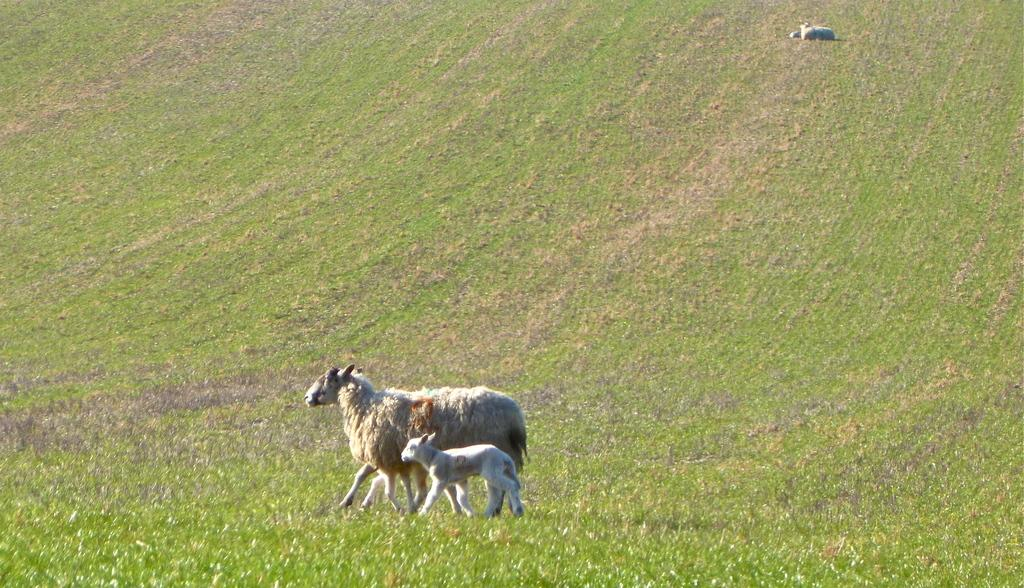What type of vegetation is present on the ground in the image? There is grass on the ground in the image. What animals can be seen in the image? There is a sheep and a lamb in the image. Can you describe the position of the animal at the top of the image? There is an animal sitting at the top of the image. Where is the ghost in the image? There is no ghost present in the image. What type of skin is visible on the sheep in the image? The image does not provide enough detail to determine the type of skin on the sheep. 